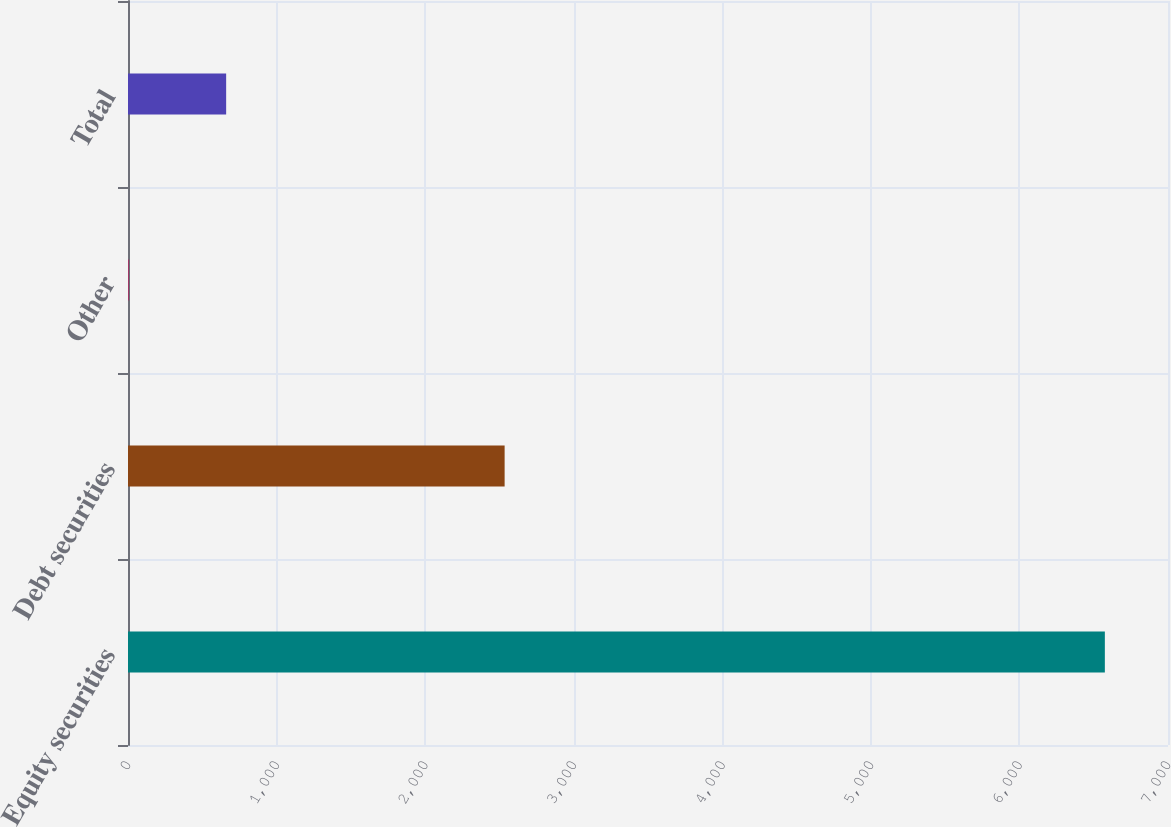<chart> <loc_0><loc_0><loc_500><loc_500><bar_chart><fcel>Equity securities<fcel>Debt securities<fcel>Other<fcel>Total<nl><fcel>6575<fcel>2535<fcel>3.47<fcel>660.62<nl></chart> 